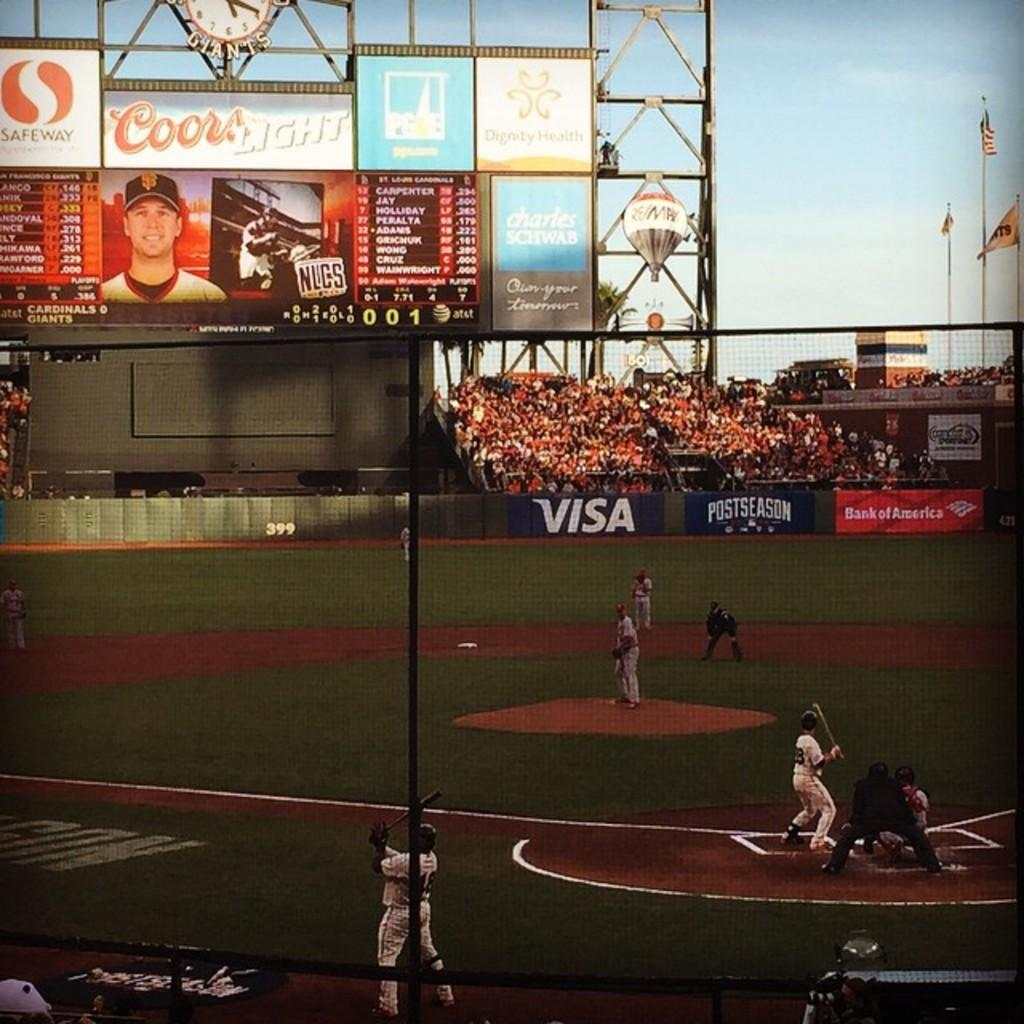<image>
Share a concise interpretation of the image provided. baseball players on a field sponsored by Visa and Coors 